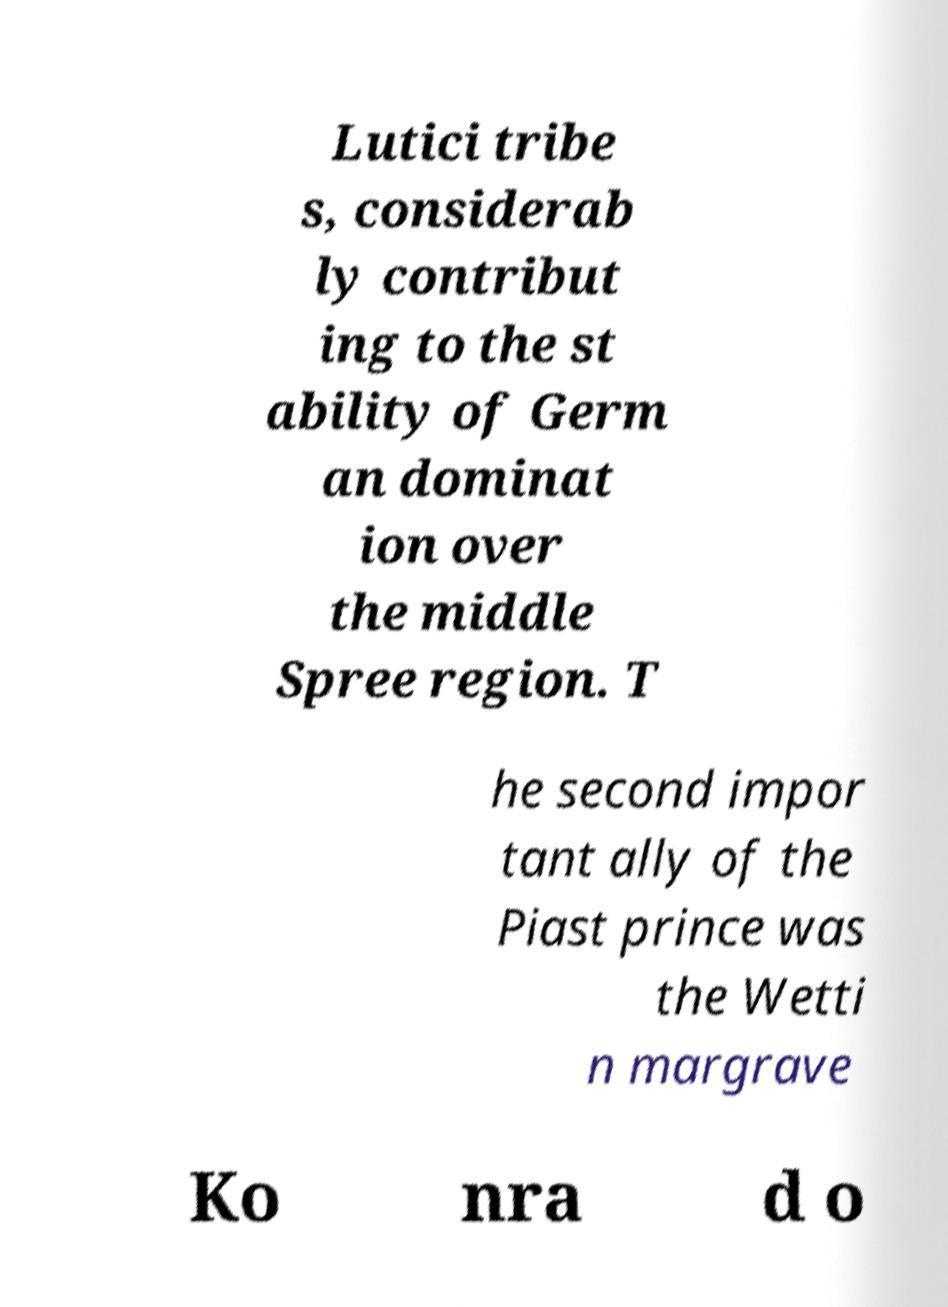Could you assist in decoding the text presented in this image and type it out clearly? Lutici tribe s, considerab ly contribut ing to the st ability of Germ an dominat ion over the middle Spree region. T he second impor tant ally of the Piast prince was the Wetti n margrave Ko nra d o 